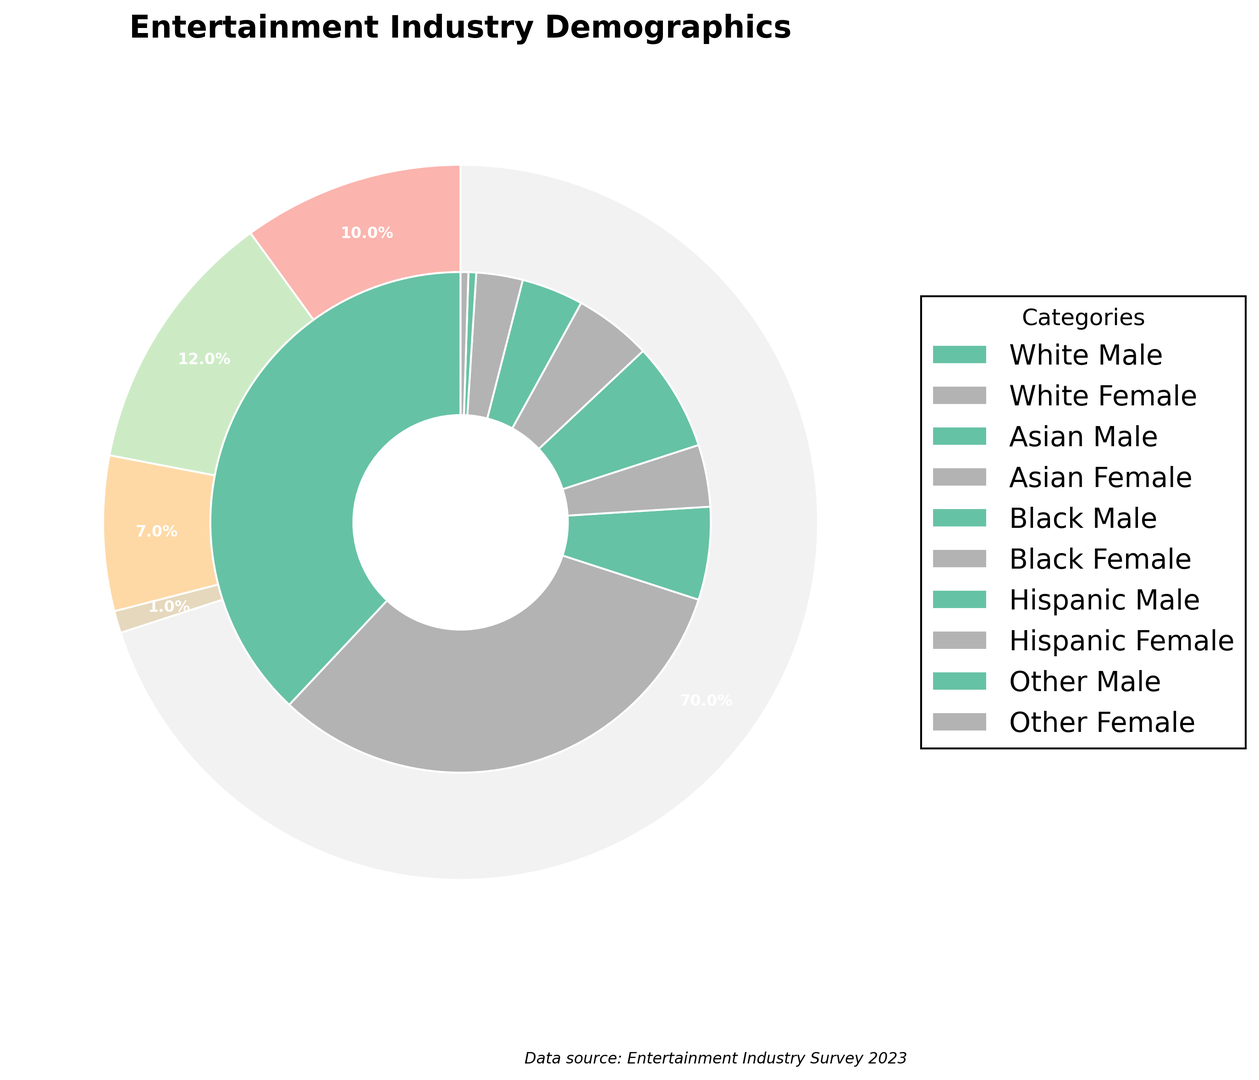What's the total percentage of white individuals in the entertainment industry? To calculate the total percentage of white individuals, sum the percentages of white males and white females: 38% + 32% = 70%.
Answer: 70% Which gender has a higher percentage representation in the Asian category? Compare the percentages of Asian males (6%) and Asian females (4%). Since 6% is greater than 4%, Asian males have a higher representation.
Answer: Male What is the combined percentage of black and Hispanic females in the entertainment industry? Add the percentage of black females (5%) to the percentage of Hispanic females (3%): 5% + 3% = 8%.
Answer: 8% Who has the smallest representation in the chart, and what is their percentage? By examining the chart, we see that both 'Other Male' and 'Other Female' have the smallest representation, each at 0.5%.
Answer: Other Female, Other Male What is the percentage difference between white and black males in the industry? Subtract the percentage of black males (7%) from the percentage of white males (38%): 38% - 7% = 31%.
Answer: 31% Compare the total percentage of males to the total percentage of females in the entertainment industry. Which gender has a higher percentage, and by how much? First, sum the percentages of all males (38% + 6% + 7% + 4% + 0.5% = 55.5%) and all females (32% + 4% + 5% + 3% + 0.5% = 44.5%). Then, subtract the total percentage of females from the males: 55.5% - 44.5% = 11%. Males have a higher percentage by 11%.
Answer: Male, 11% Which category has the highest representation, and what is the percentage? By examining the chart, the White category has the highest representation with a combined percentage of 70% (38% for males + 32% for females).
Answer: White, 70% 